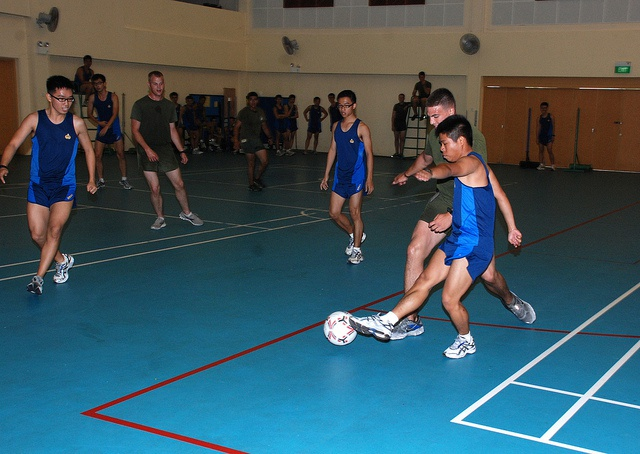Describe the objects in this image and their specific colors. I can see people in gray, black, salmon, brown, and blue tones, people in gray, brown, navy, black, and maroon tones, people in gray, black, salmon, and brown tones, people in gray, black, maroon, and brown tones, and people in gray, navy, black, brown, and maroon tones in this image. 